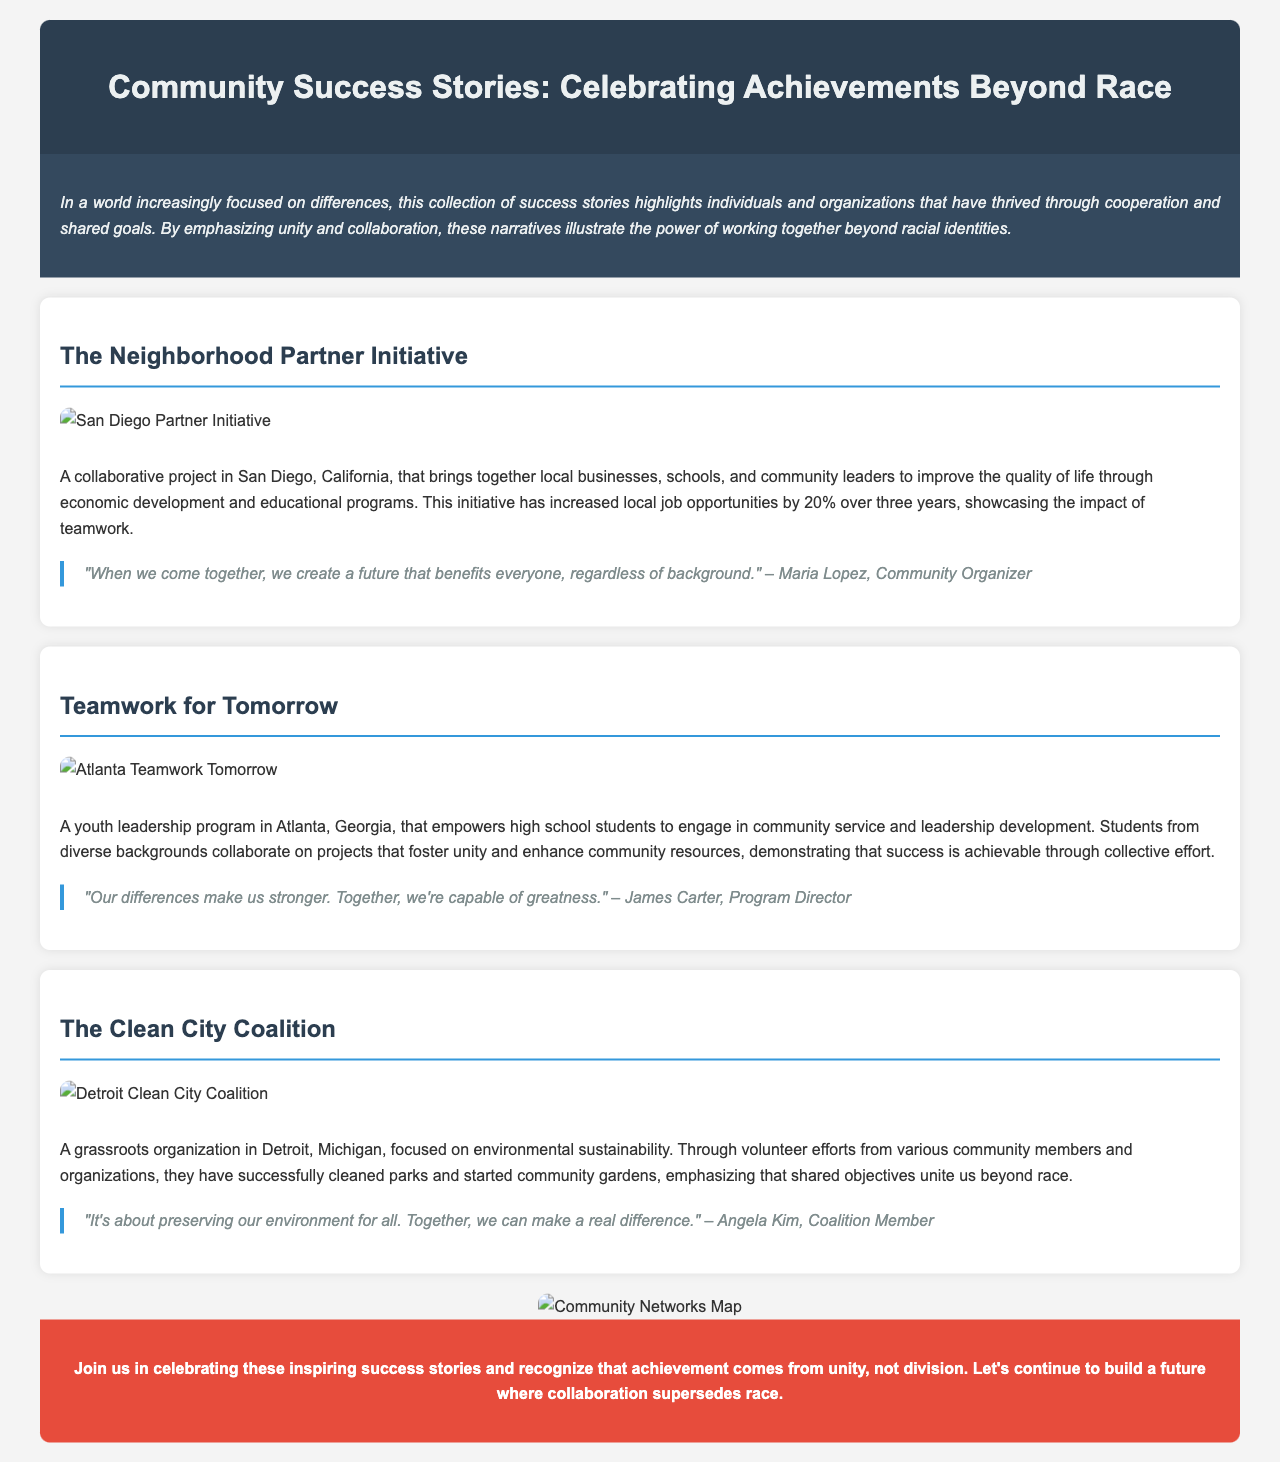What is the title of the brochure? The title is prominently displayed at the top of the document, indicating the main theme of the collection.
Answer: Community Success Stories: Celebrating Achievements Beyond Race How many success stories are featured in the brochure? There are three distinct success stories presented in the brochure, showcasing various initiatives.
Answer: 3 What city is associated with The Neighborhood Partner Initiative? The specific city mentioned in relation to the initiative is highlighted in the introduction of the success story.
Answer: San Diego Who is the Program Director of Teamwork for Tomorrow? The name of the Program Director is quoted in the success story for Teamwork for Tomorrow.
Answer: James Carter What percentage of job opportunities increased due to The Neighborhood Partner Initiative? The specific percentage of job opportunities is mentioned in the description of the success story.
Answer: 20% What type of organization is The Clean City Coalition? The nature of The Clean City Coalition is specified to indicate its focus and community involvement in the narrative.
Answer: Grassroots What is emphasized as the main reason for community success in the brochure? The brochure clearly states the underlying theme that connects all success stories, guiding the reader's understanding.
Answer: Unity and collaboration What kind of map is included in the brochure? The type of visual element included to highlight community networks is explicitly stated in the document.
Answer: Community Networks Map 